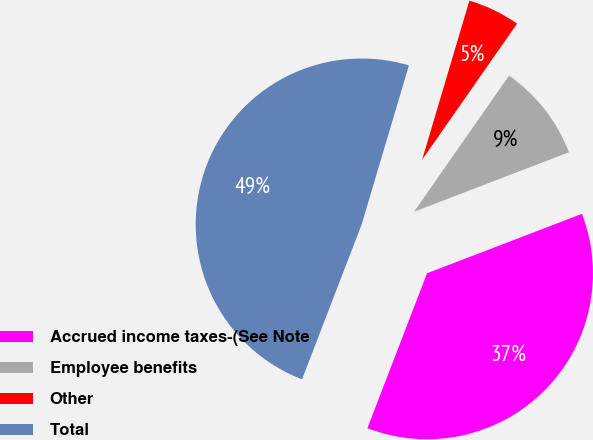Convert chart. <chart><loc_0><loc_0><loc_500><loc_500><pie_chart><fcel>Accrued income taxes-(See Note<fcel>Employee benefits<fcel>Other<fcel>Total<nl><fcel>36.68%<fcel>9.47%<fcel>5.1%<fcel>48.75%<nl></chart> 